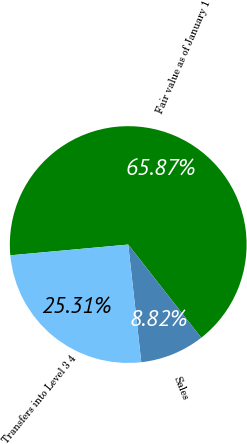Convert chart. <chart><loc_0><loc_0><loc_500><loc_500><pie_chart><fcel>Fair value as of January 1<fcel>Sales<fcel>Transfers into Level 3 4<nl><fcel>65.86%<fcel>8.82%<fcel>25.31%<nl></chart> 